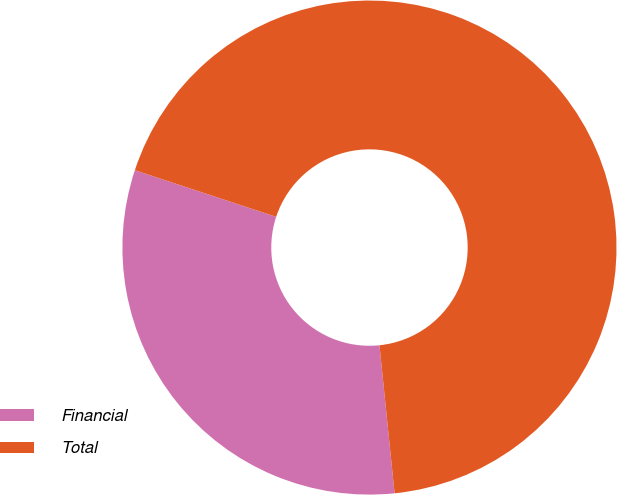Convert chart to OTSL. <chart><loc_0><loc_0><loc_500><loc_500><pie_chart><fcel>Financial<fcel>Total<nl><fcel>31.69%<fcel>68.31%<nl></chart> 